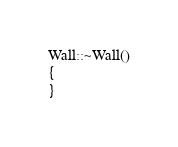Convert code to text. <code><loc_0><loc_0><loc_500><loc_500><_C++_>
Wall::~Wall()
{
}
</code> 